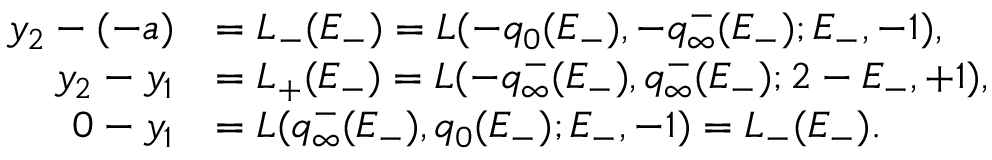Convert formula to latex. <formula><loc_0><loc_0><loc_500><loc_500>\begin{array} { r l } { y _ { 2 } - ( - a ) } & { = L _ { - } ( E _ { - } ) = L ( - q _ { 0 } ( E _ { - } ) , - q _ { \infty } ^ { - } ( E _ { - } ) ; E _ { - } , - 1 ) , } \\ { y _ { 2 } - y _ { 1 } } & { = L _ { + } ( E _ { - } ) = L ( - q _ { \infty } ^ { - } ( E _ { - } ) , q _ { \infty } ^ { - } ( E _ { - } ) ; 2 - E _ { - } , + 1 ) , } \\ { 0 - y _ { 1 } } & { = L ( q _ { \infty } ^ { - } ( E _ { - } ) , q _ { 0 } ( E _ { - } ) ; E _ { - } , - 1 ) = L _ { - } ( E _ { - } ) . } \end{array}</formula> 